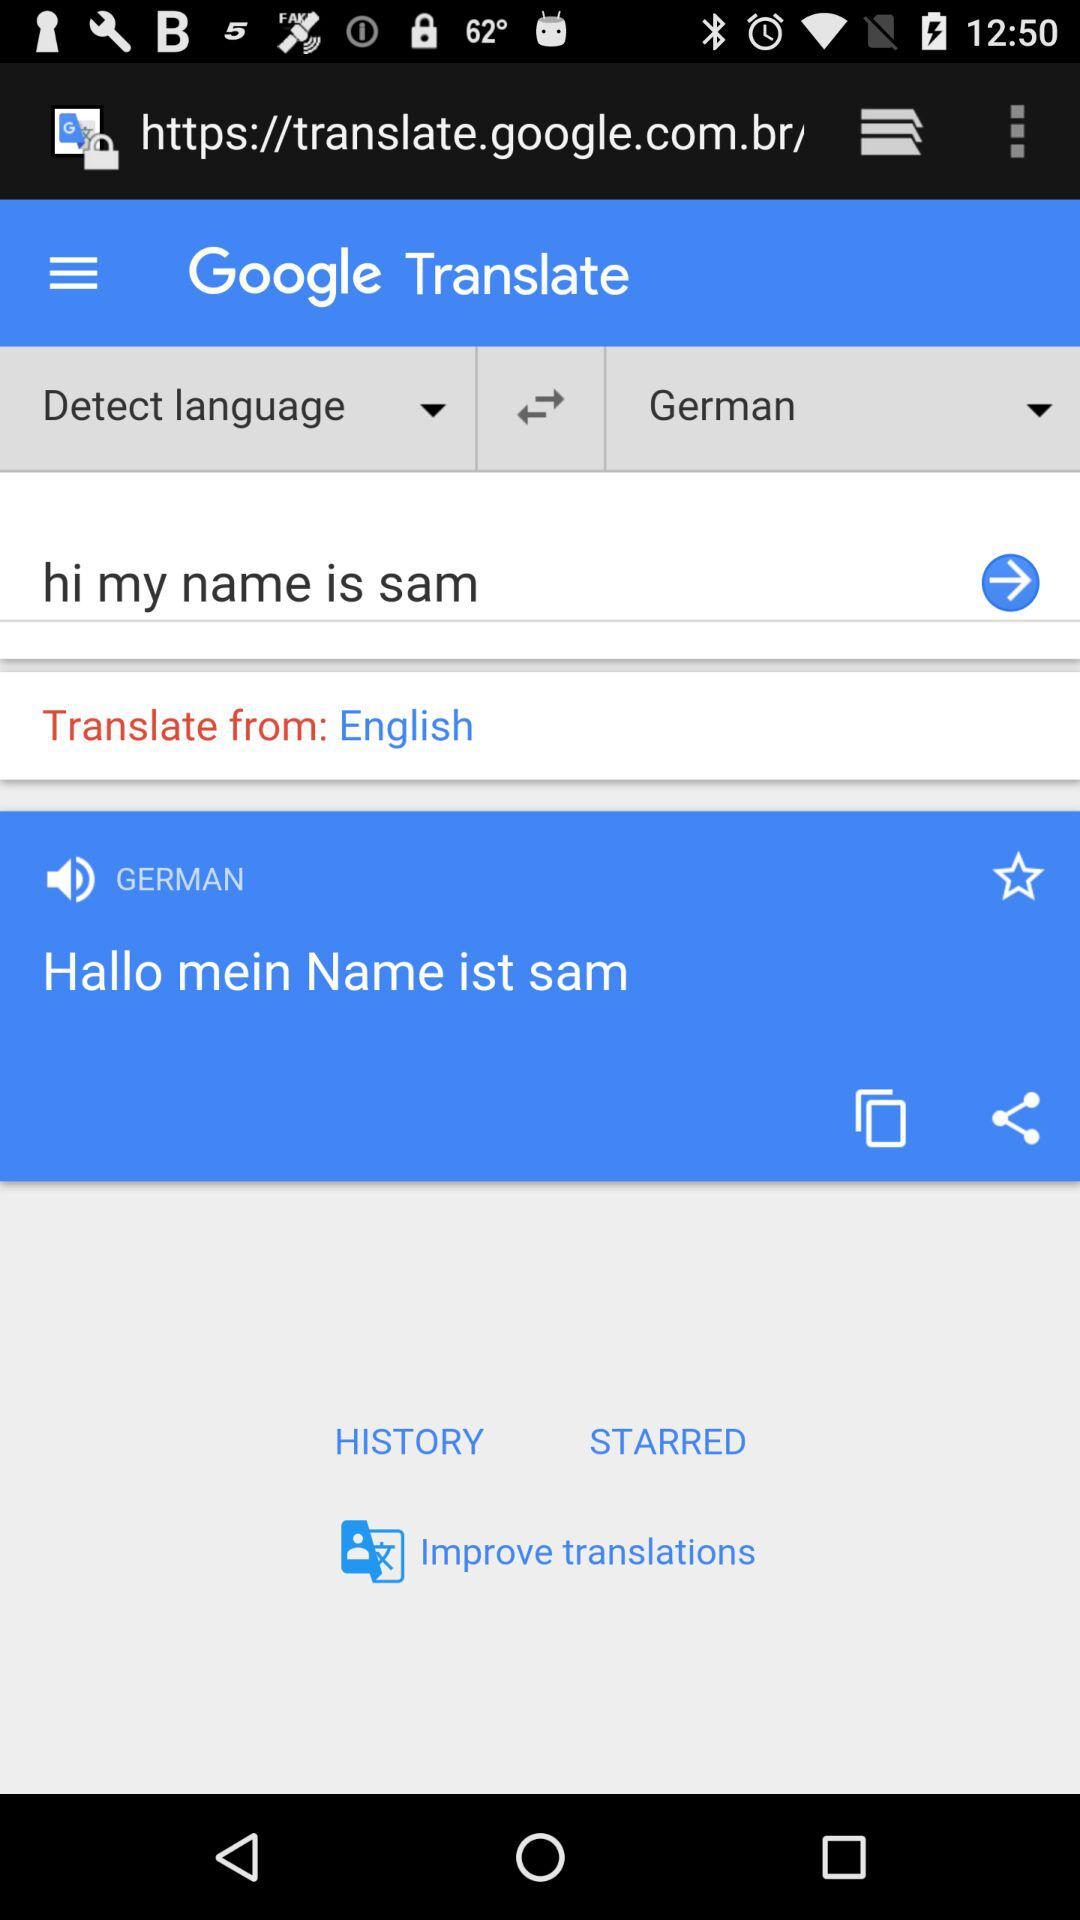In which language is the text translated? The text is translated into the German language. 